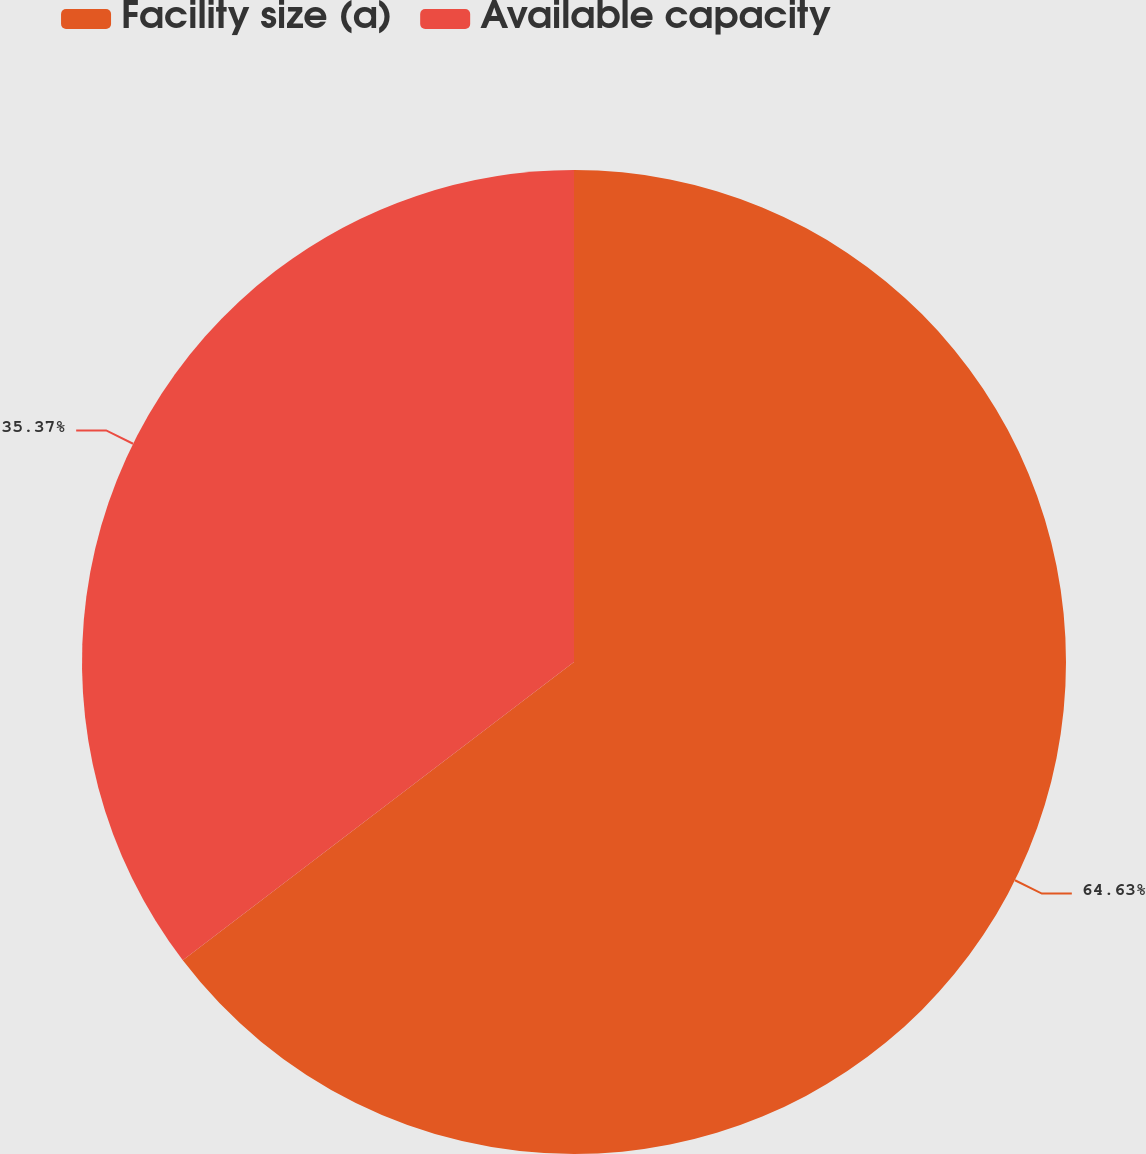Convert chart. <chart><loc_0><loc_0><loc_500><loc_500><pie_chart><fcel>Facility size (a)<fcel>Available capacity<nl><fcel>64.63%<fcel>35.37%<nl></chart> 